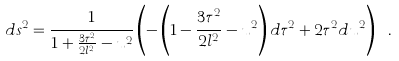Convert formula to latex. <formula><loc_0><loc_0><loc_500><loc_500>d s ^ { 2 } = \frac { 1 } { 1 + \frac { 3 { \tau } ^ { 2 } } { 2 l ^ { 2 } } - u ^ { 2 } } \left ( - \left ( 1 - \frac { 3 { \tau } ^ { 2 } } { 2 l ^ { 2 } } - u ^ { 2 } \right ) d { \tau } ^ { 2 } + 2 { \tau } ^ { 2 } d u ^ { 2 } \right ) \ .</formula> 